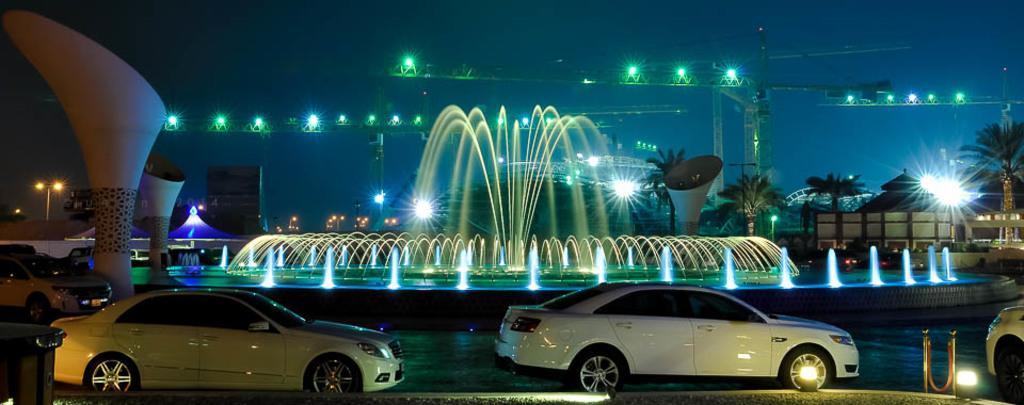How would you summarize this image in a sentence or two? In this image we can see some cars which are moving on road and we can see water fountain in which there are some lights and in the background of the image there are some trees, houses and cranes. 